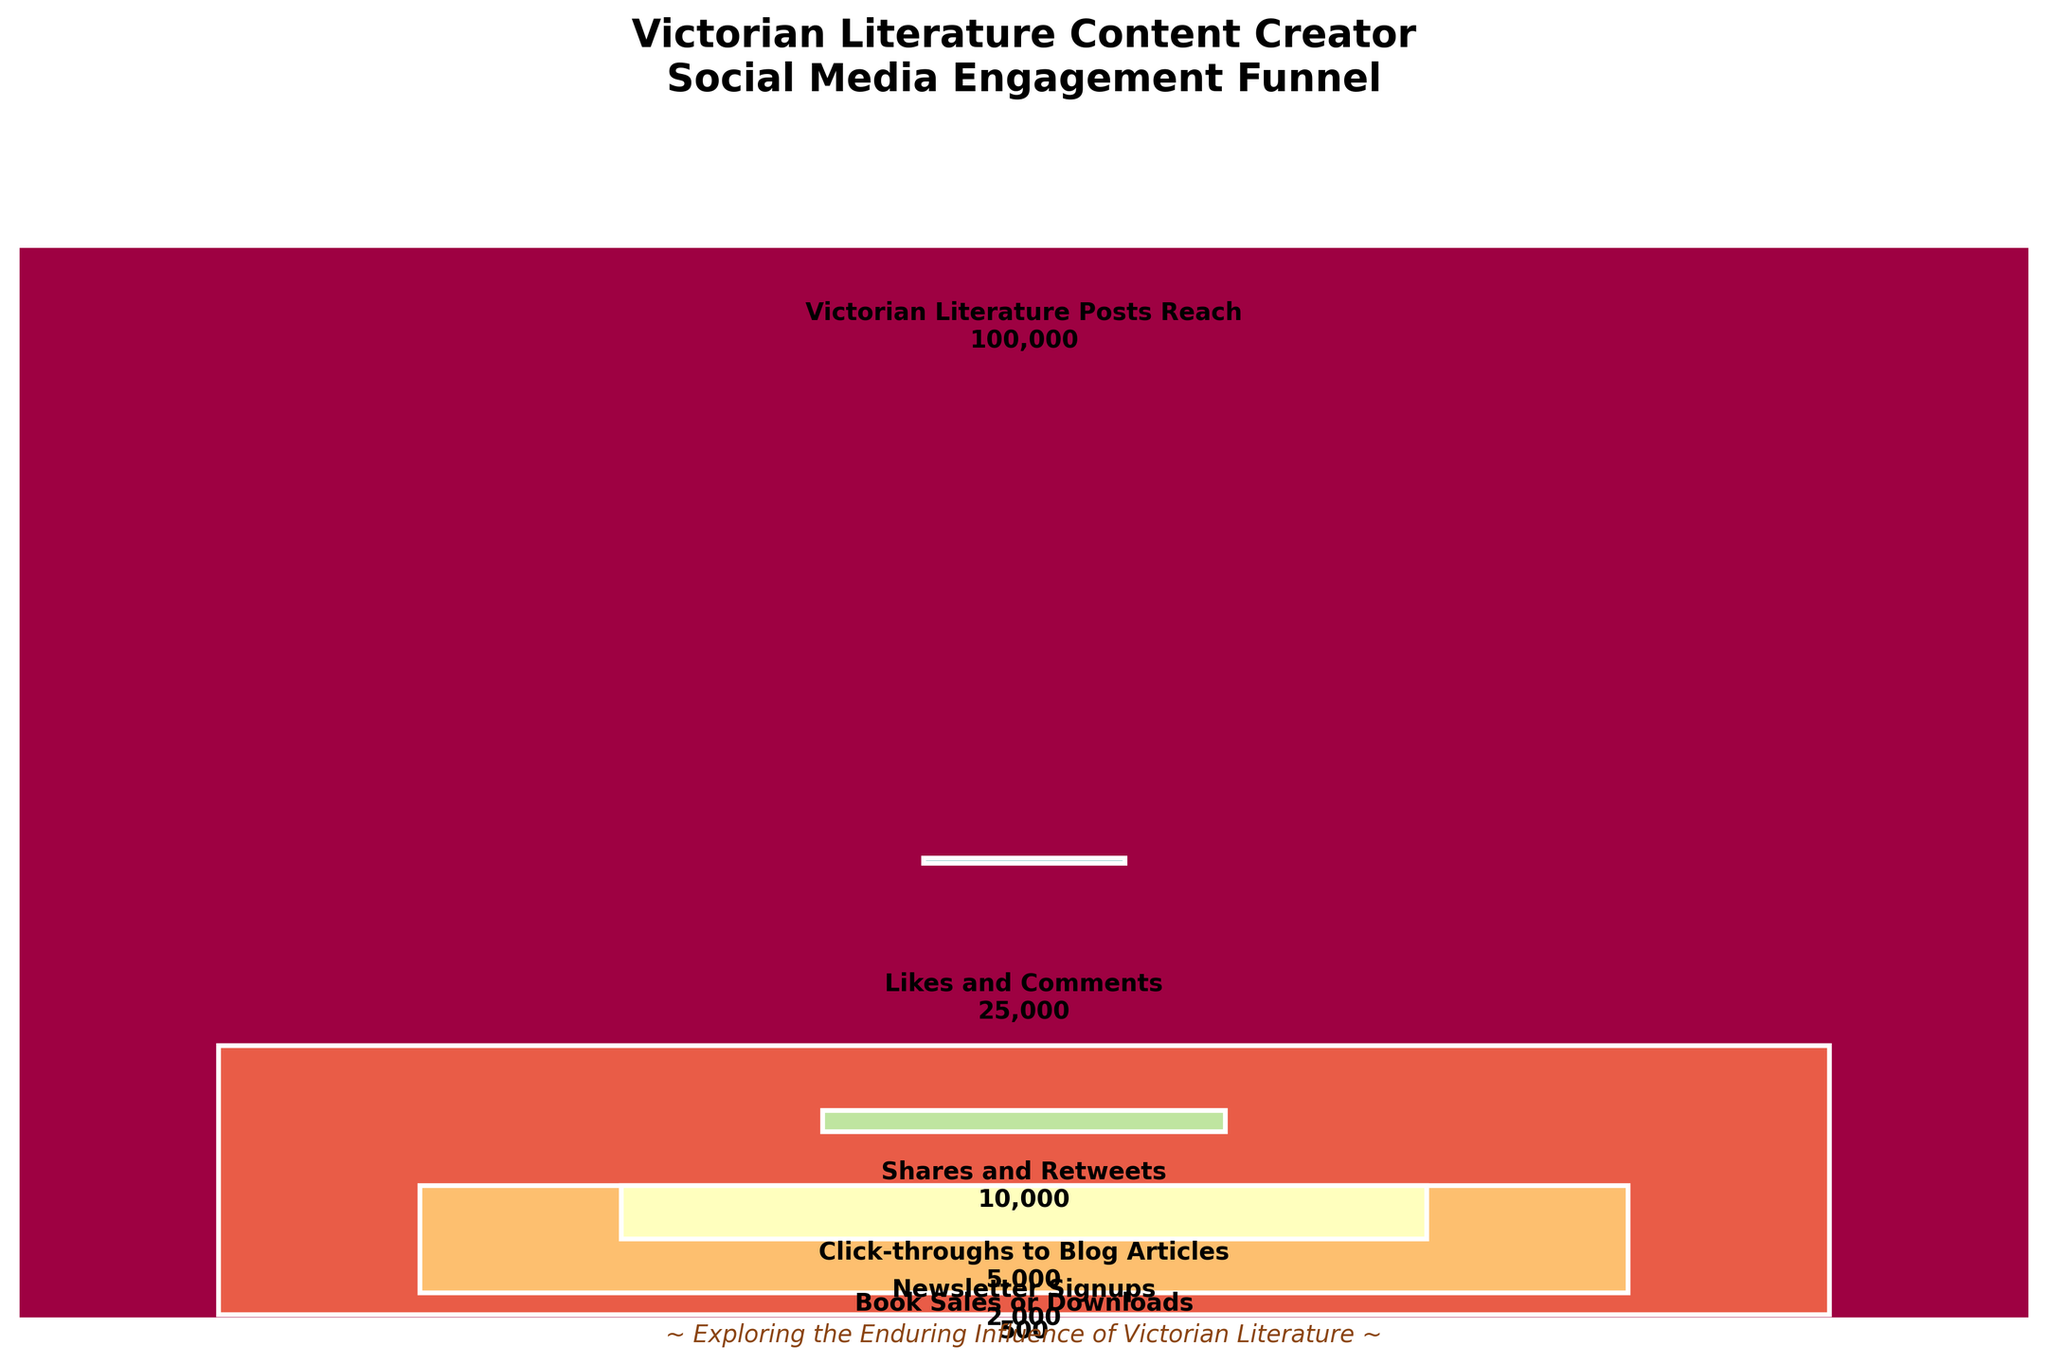What is the title of the funnel chart? The title is typically located at the top of the chart. In this case, it reads "Victorian Literature Content Creator Social Media Engagement Funnel".
Answer: Victorian Literature Content Creator Social Media Engagement Funnel How many stages are represented in the funnel? By examining the chart, we can see different sections separated by bars. Each bar represents a stage. Counting these sections gives us 5 stages.
Answer: 5 Which stage has the highest number of users? The section with the tallest bar represents the stage with the highest number of users. The tallest bar, labeled at the bottom, is "Victorian Literature Posts Reach" with 100,000 users.
Answer: Victorian Literature Posts Reach What is the drop in users from the Likes and Comments stage to the Shares and Retweets stage? To find the drop, we subtract the number of users in the Shares and Retweets stage (10,000) from the users in the Likes and Comments stage (25,000): 25,000 - 10,000 = 15,000.
Answer: 15,000 Which stage represents the lowest engagement and how many users are in this stage? The smallest section or the shortest bar indicates the stage with the lowest engagement. This is the "Book Sales or Downloads" stage with 500 users.
Answer: Book Sales or Downloads, 500 By how much do Click-throughs to Blog Articles exceed Newsletter Signups? We subtract the users in Newsletter Signups (2,000) from the users in Click-throughs to Blog Articles (5,000): 5,000 - 2,000 = 3,000.
Answer: 3,000 Compare the percentage drop from Victorian Literature Posts Reach to Likes and Comments, and from Click-throughs to Blog Articles to Book Sales or Downloads. Which is greater? First, calculate the percentage drop in both cases. For "Victorian Literature Posts Reach" to "Likes and Comments", 100,000 - 25,000 = 75,000, which is 75,000 / 100,000 = 75%. For "Click-throughs to Blog Articles" to "Book Sales or Downloads", 5,000 - 500 = 4,500, which is 4,500 / 5,000 = 90%. The drop of 90% is greater.
Answer: 90% drop (Click-throughs to Book Sales) 